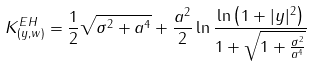Convert formula to latex. <formula><loc_0><loc_0><loc_500><loc_500>K ^ { E H } _ { ( y , w ) } = \frac { 1 } { 2 } \sqrt { \sigma ^ { 2 } + a ^ { 4 } } + \frac { a ^ { 2 } } { 2 } \ln \frac { \ln \left ( 1 + | y | ^ { 2 } \right ) } { 1 + \sqrt { 1 + \frac { \sigma ^ { 2 } } { a ^ { 4 } } } }</formula> 